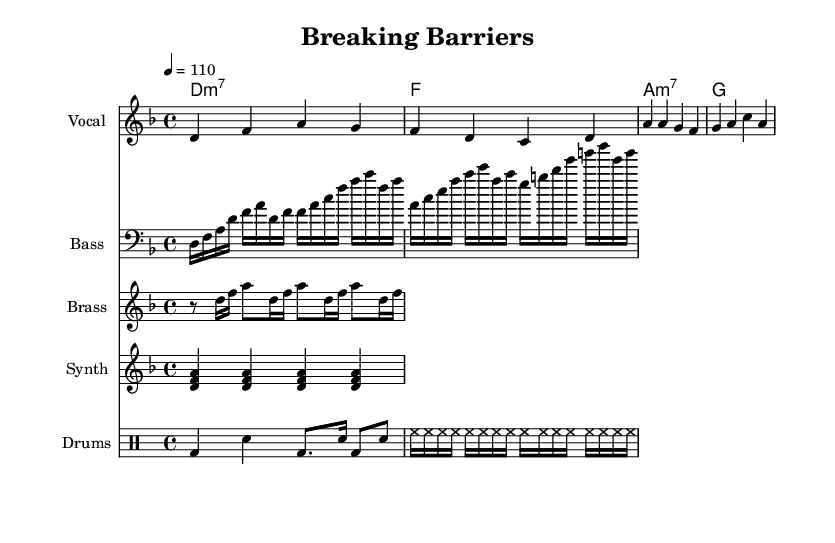What is the key signature of this music? The key signature shows two flats, indicating that the music is in D minor; note that D minor is the relative minor of F major, which has one flat.
Answer: D minor What is the time signature of the piece? The time signature shown at the beginning of the score is 4/4, which indicates that there are four beats in each measure, and the quarter note gets one beat.
Answer: 4/4 What is the tempo marking for this piece? The tempo marking indicates 4 beats per minute at 110, meaning the music should be played at a moderate pace, which is common for funk.
Answer: 110 How many measures are in the vocal melody? The vocal melody consists of the two sections presented in the measure, eight measures in total are visible in this part of the score.
Answer: Eight Which instrument plays the bass line? The bass line is labeled in the score as "Bass," meaning this staff is specifically designated for the bass instrument, which provides a harmonic foundation in funk music.
Answer: Bass What type of chords are used in the chord progression? The chord progression indicates the use of minor 7 (m7) chords as well as a major chord, representative of funk's jazzy and syncopated style associated with improvisation.
Answer: Minor 7 What rhythmic element is prominent in the drum part? The drum part shows a combination of bass drum sounds, snare notes, and high-hat rhythms, characteristic of funk music's strong backbeat and syncopation that drive the groove.
Answer: Strong backbeat 